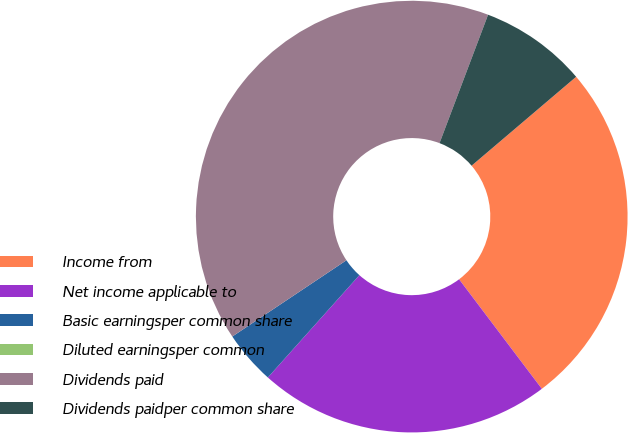Convert chart to OTSL. <chart><loc_0><loc_0><loc_500><loc_500><pie_chart><fcel>Income from<fcel>Net income applicable to<fcel>Basic earningsper common share<fcel>Diluted earningsper common<fcel>Dividends paid<fcel>Dividends paidper common share<nl><fcel>25.92%<fcel>21.91%<fcel>4.01%<fcel>0.0%<fcel>40.13%<fcel>8.03%<nl></chart> 